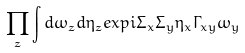Convert formula to latex. <formula><loc_0><loc_0><loc_500><loc_500>\prod _ { z } \int d \omega _ { z } d \eta _ { z } e x p i \Sigma _ { x } \Sigma _ { y } \eta _ { x } \Gamma _ { x y } \omega _ { y }</formula> 